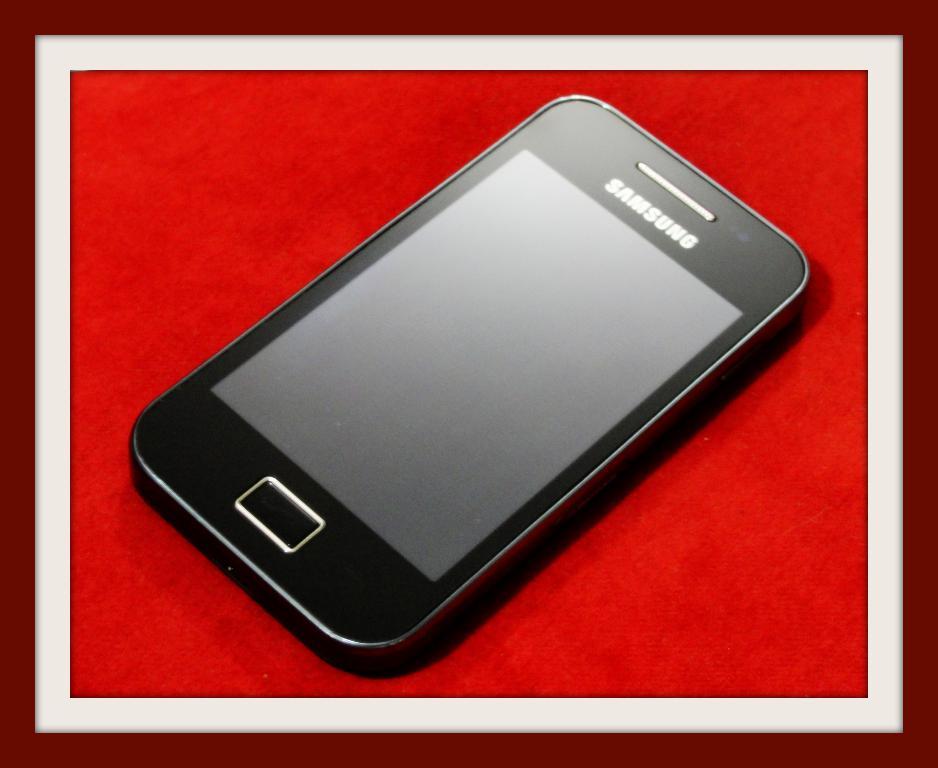What brand is this phone?
Your response must be concise. Samsung. What word can you make with the first three letters of the brand name?
Ensure brevity in your answer.  Sam. 